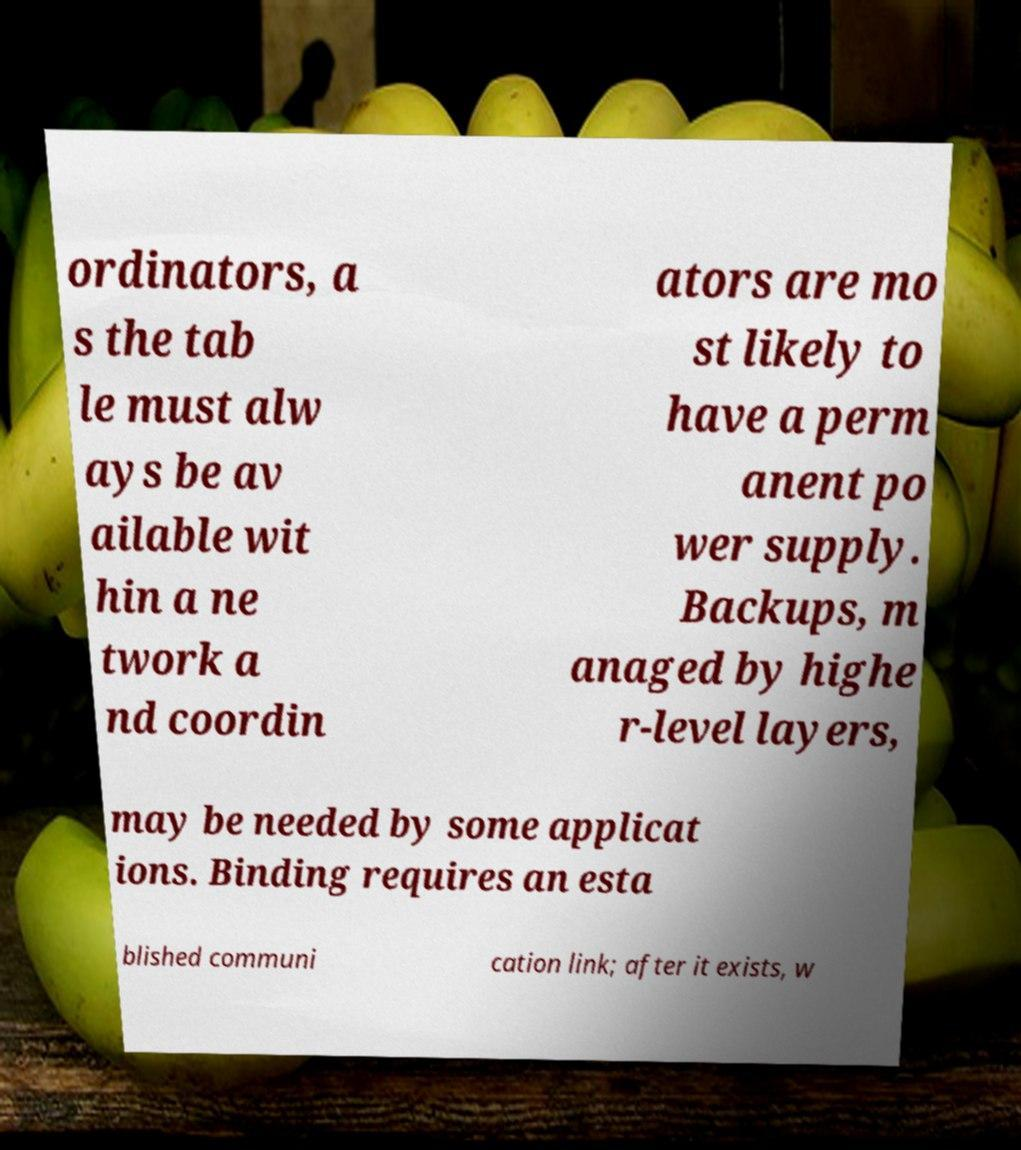Please identify and transcribe the text found in this image. ordinators, a s the tab le must alw ays be av ailable wit hin a ne twork a nd coordin ators are mo st likely to have a perm anent po wer supply. Backups, m anaged by highe r-level layers, may be needed by some applicat ions. Binding requires an esta blished communi cation link; after it exists, w 